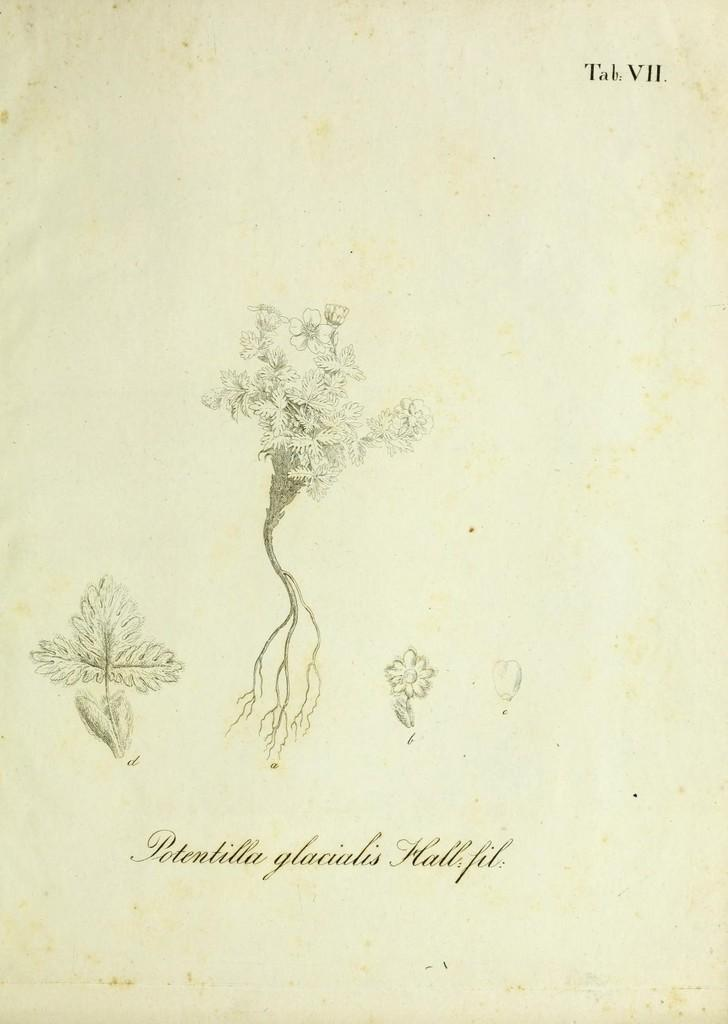What is depicted in the painting in the image? There is a painting of a plant in the image. What specific parts of the plant can be seen in the painting? The painting includes leaves and a flower in the middle. Is there any text associated with the painting in the image? Yes, there is text written at the bottom of the image. What type of leather material can be seen in the image? There is no leather material present in the image; it features a painting of a plant with text at the bottom. Can you describe the toes of the plant in the image? Plants do not have toes, as they are not living organisms with feet. 